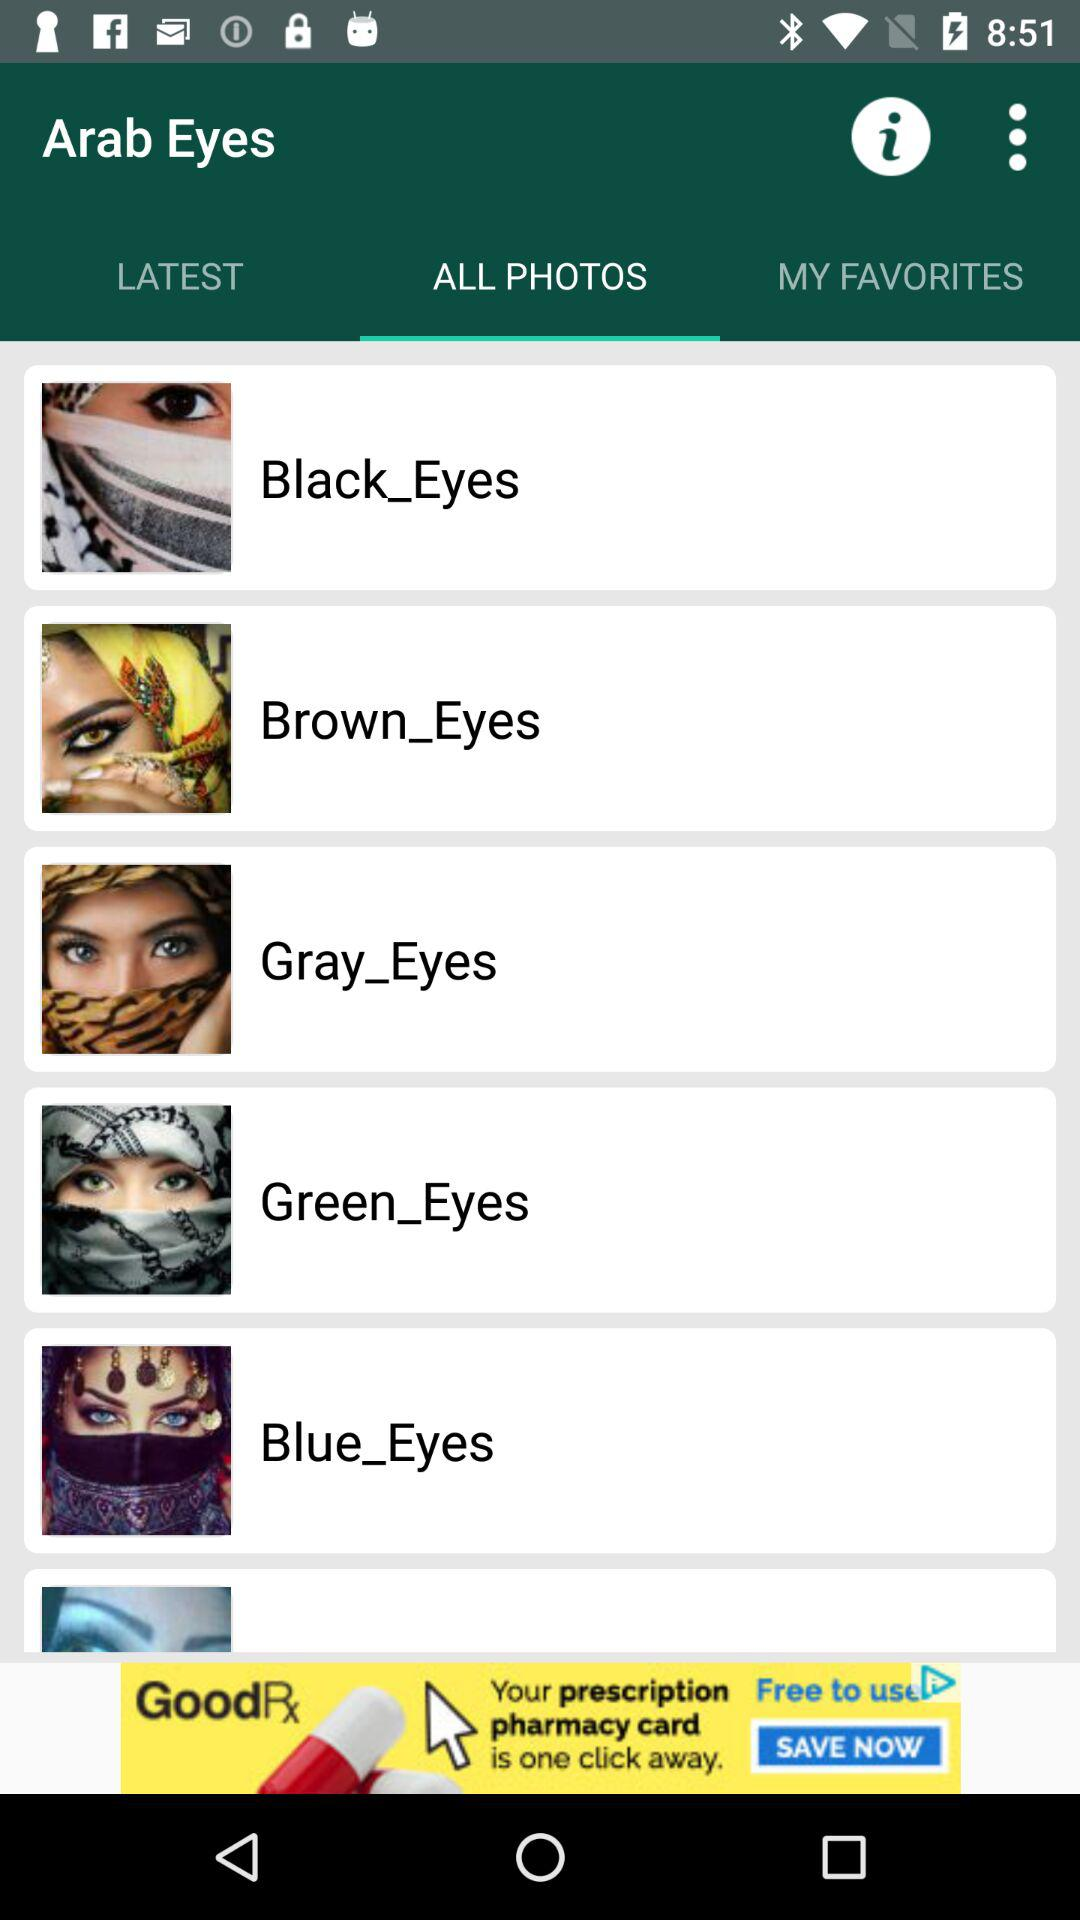Which option is selected? The selected option is "ALL PHOTOS". 